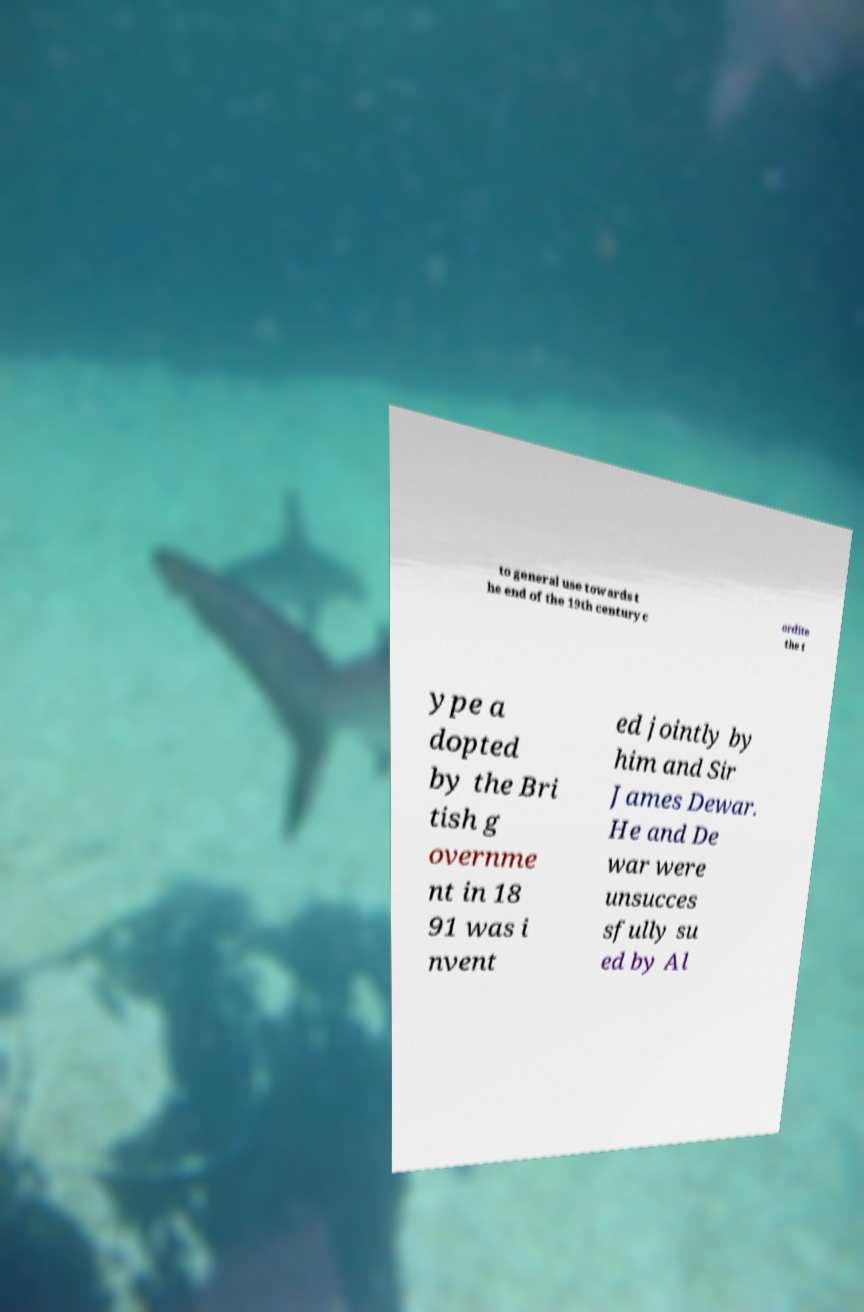Could you extract and type out the text from this image? to general use towards t he end of the 19th century c ordite the t ype a dopted by the Bri tish g overnme nt in 18 91 was i nvent ed jointly by him and Sir James Dewar. He and De war were unsucces sfully su ed by Al 